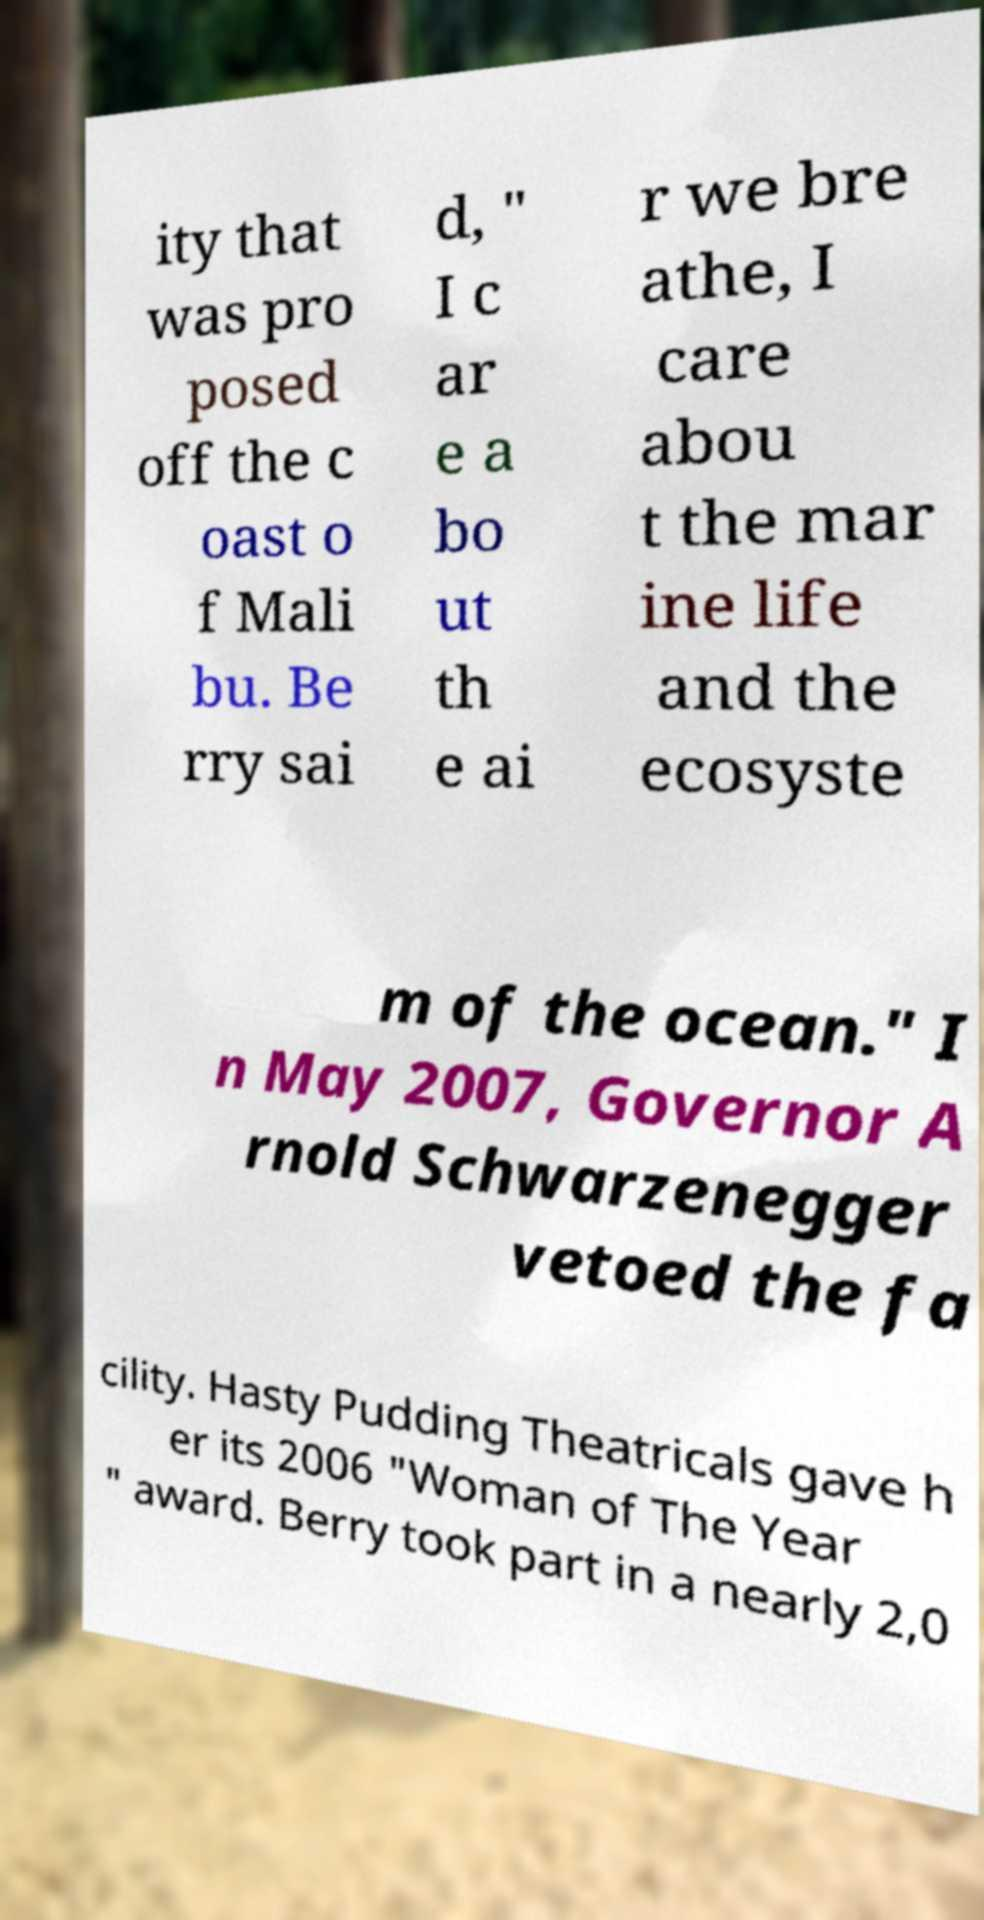Please identify and transcribe the text found in this image. ity that was pro posed off the c oast o f Mali bu. Be rry sai d, " I c ar e a bo ut th e ai r we bre athe, I care abou t the mar ine life and the ecosyste m of the ocean." I n May 2007, Governor A rnold Schwarzenegger vetoed the fa cility. Hasty Pudding Theatricals gave h er its 2006 "Woman of The Year " award. Berry took part in a nearly 2,0 